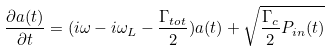Convert formula to latex. <formula><loc_0><loc_0><loc_500><loc_500>\frac { \partial a ( t ) } { \partial t } = ( i \omega - i \omega _ { L } - \frac { \Gamma _ { t o t } } { 2 } ) a ( t ) + \sqrt { \frac { \Gamma _ { c } } { 2 } P _ { i n } ( t ) }</formula> 